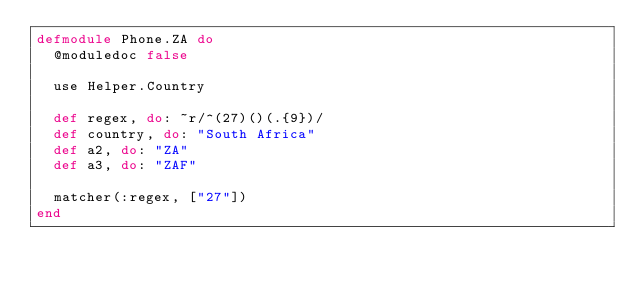Convert code to text. <code><loc_0><loc_0><loc_500><loc_500><_Elixir_>defmodule Phone.ZA do
  @moduledoc false

  use Helper.Country

  def regex, do: ~r/^(27)()(.{9})/
  def country, do: "South Africa"
  def a2, do: "ZA"
  def a3, do: "ZAF"

  matcher(:regex, ["27"])
end
</code> 